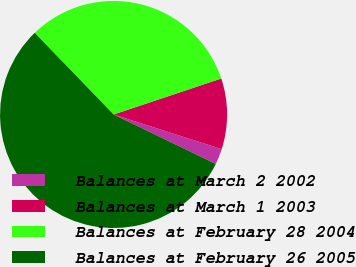Convert chart to OTSL. <chart><loc_0><loc_0><loc_500><loc_500><pie_chart><fcel>Balances at March 2 2002<fcel>Balances at March 1 2003<fcel>Balances at February 28 2004<fcel>Balances at February 26 2005<nl><fcel>2.24%<fcel>10.07%<fcel>32.09%<fcel>55.6%<nl></chart> 